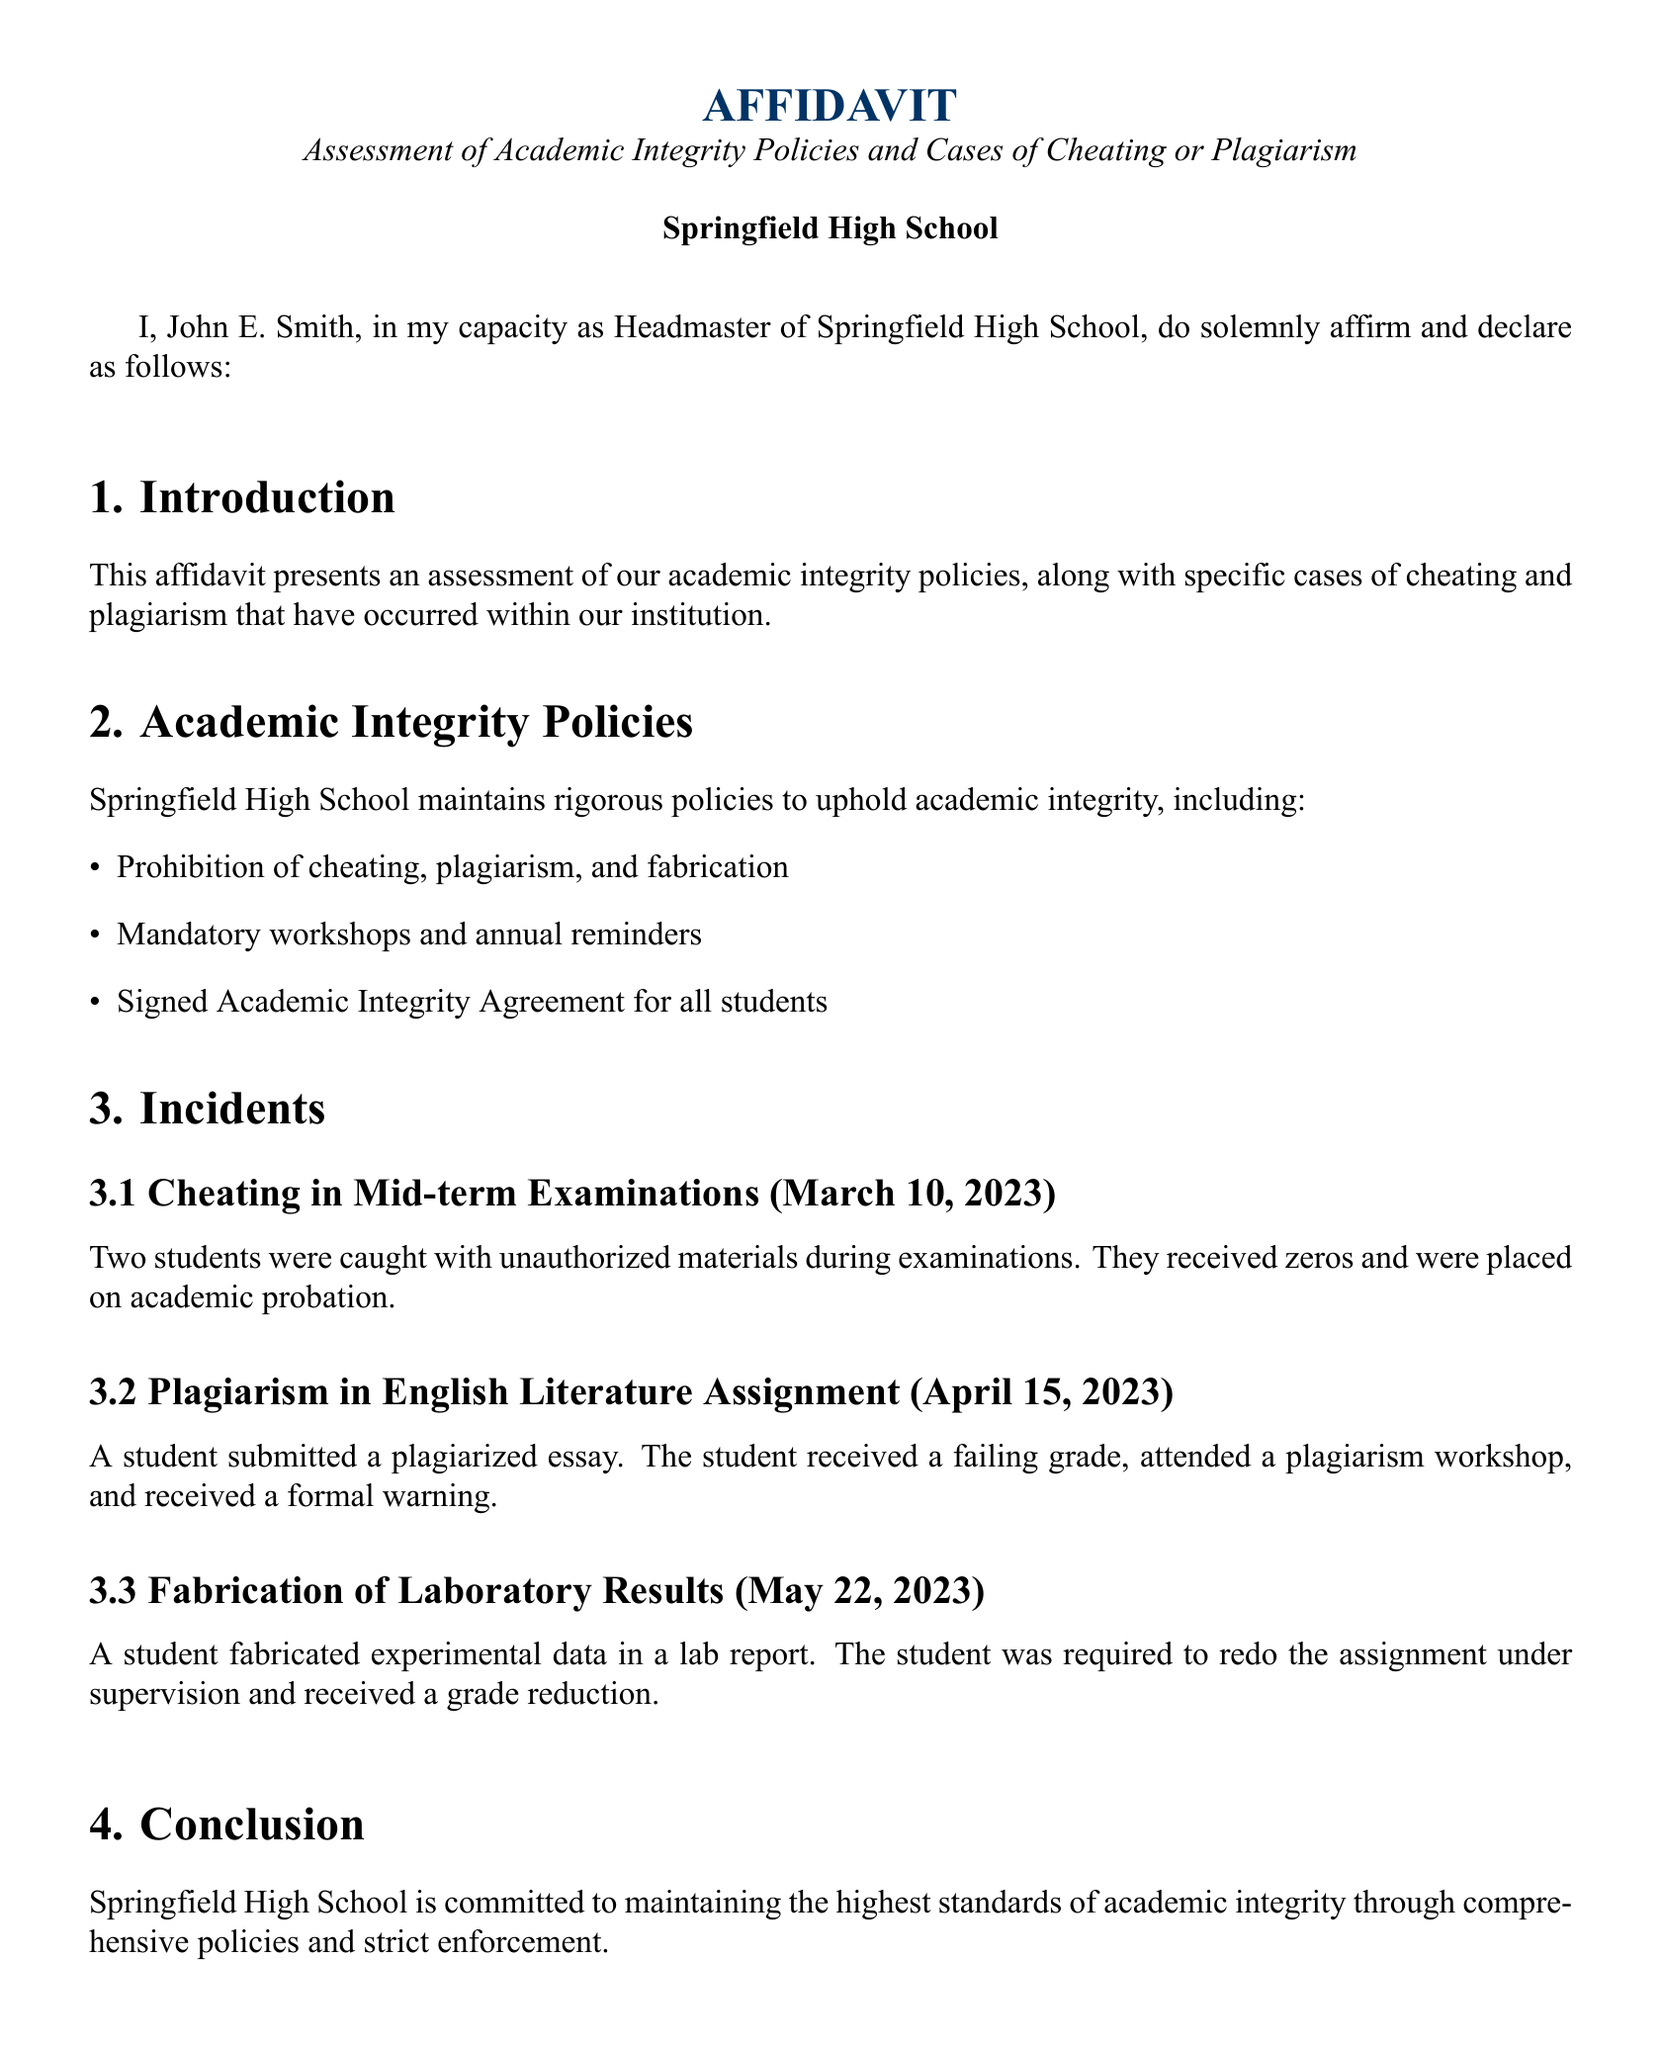What is the date of the affidavit? The date mentioned in the affidavit is when it was affirmed and declared by the Headmaster.
Answer: October 5, 2023 Who is the author of the affidavit? The affidavit is authored by the Headmaster of Springfield High School, whose name is stated in the document.
Answer: John E. Smith What incident occurred on March 10, 2023? The affidavit lists specific incidents of academic dishonesty along with their dates and details.
Answer: Cheating in Mid-term Examinations How many students were involved in the cheating incident? The document specifies the number of students involved in the cheating incident during mid-term examinations.
Answer: Two students What was the punishment for plagiarism in the English Literature Assignment? The consequences for the student found guilty of plagiarism in the document's specified incident are detailed.
Answer: Failing grade, workshop, and warning What workshop is mandatory for students? The affidavit outlines various policies, including mandatory workshops for academic integrity.
Answer: Plagiarism workshop What type of report was fabricated? The document includes a description of the type of academic work involved in the fabrication incident.
Answer: Laboratory results What is the purpose of the Academic Integrity Agreement? The affidavit details the purpose of the agreement signed by students.
Answer: Uphold academic integrity What does the school commit to maintaining? The conclusion section of the affidavit summarizes the school's dedication.
Answer: Highest standards of academic integrity 